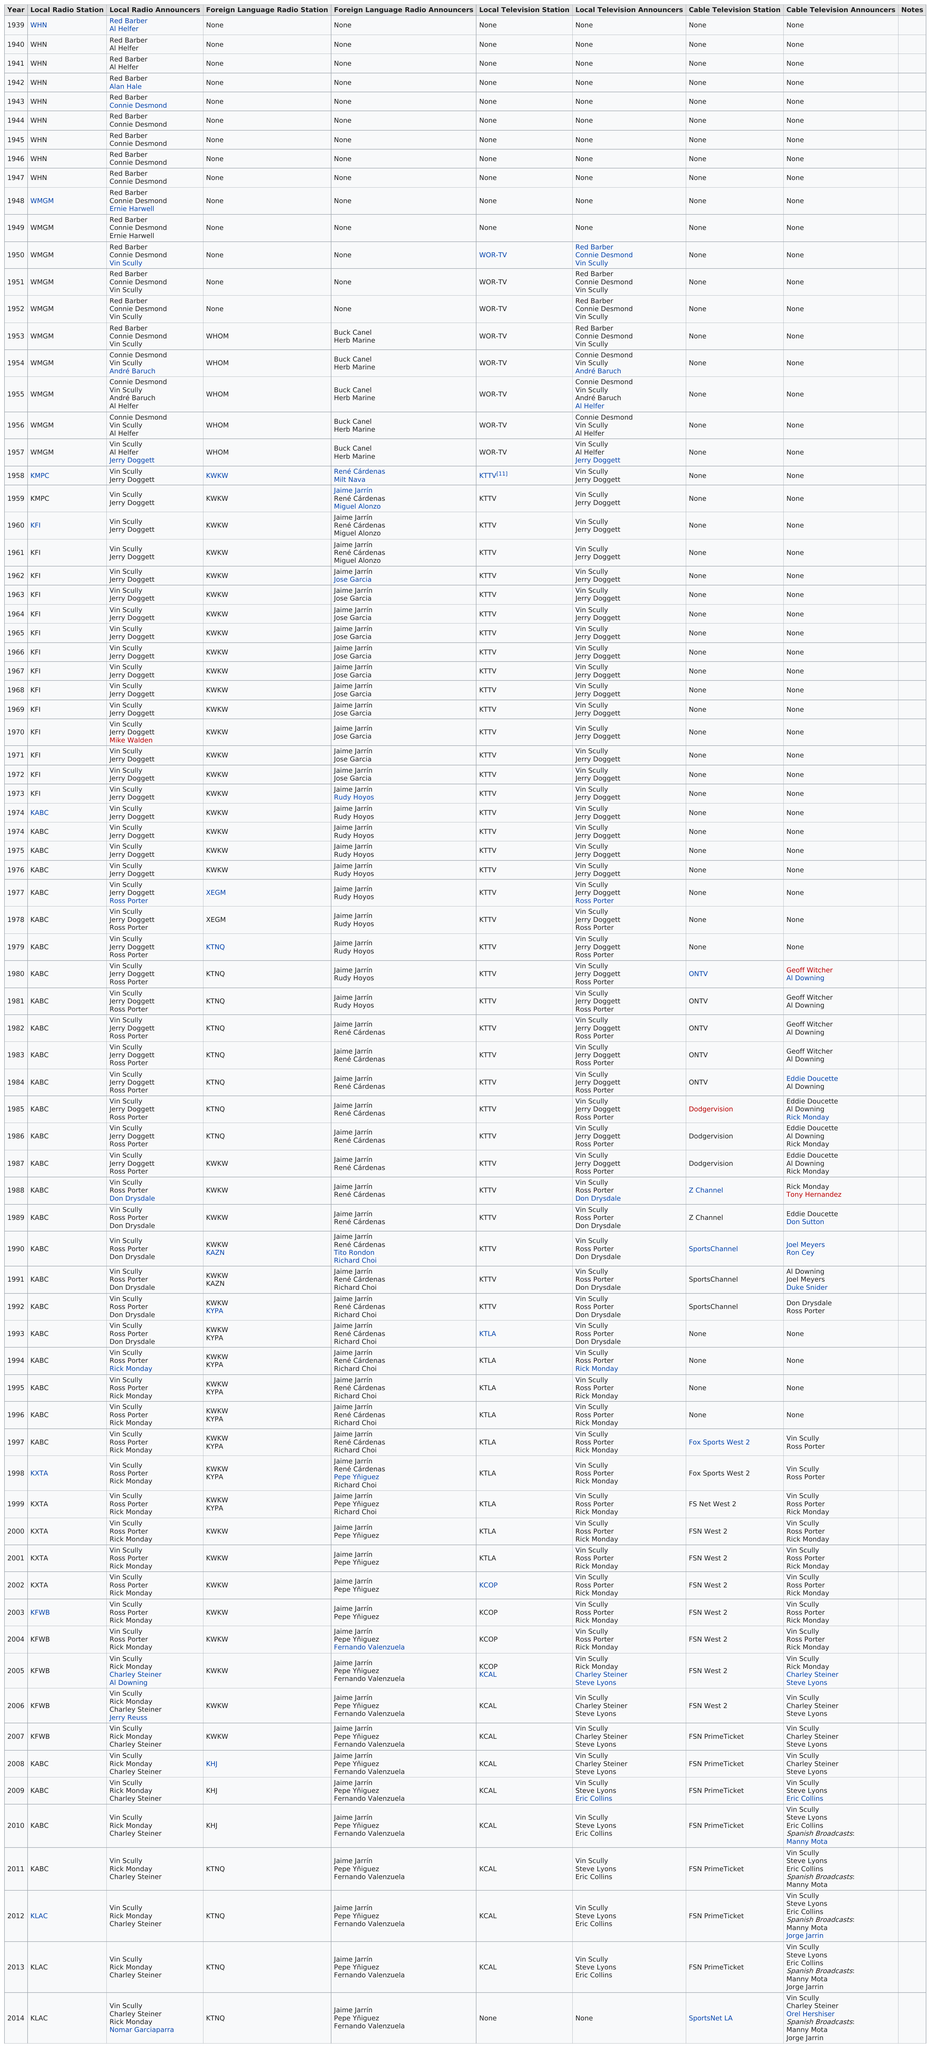Point out several critical features in this image. The broadcast of the games began on local television in 1950. The name of the cable television station that broadcasts games after OTV is Dodgervision. 